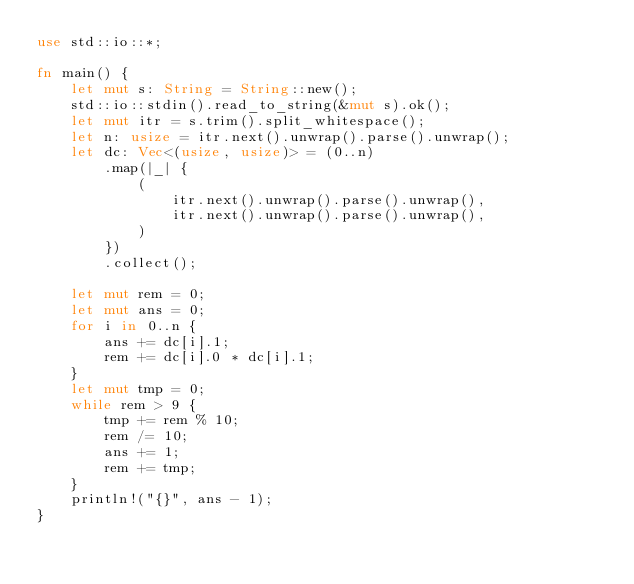Convert code to text. <code><loc_0><loc_0><loc_500><loc_500><_Rust_>use std::io::*;

fn main() {
    let mut s: String = String::new();
    std::io::stdin().read_to_string(&mut s).ok();
    let mut itr = s.trim().split_whitespace();
    let n: usize = itr.next().unwrap().parse().unwrap();
    let dc: Vec<(usize, usize)> = (0..n)
        .map(|_| {
            (
                itr.next().unwrap().parse().unwrap(),
                itr.next().unwrap().parse().unwrap(),
            )
        })
        .collect();

    let mut rem = 0;
    let mut ans = 0;
    for i in 0..n {
        ans += dc[i].1;
        rem += dc[i].0 * dc[i].1;
    }
    let mut tmp = 0;
    while rem > 9 {
        tmp += rem % 10;
        rem /= 10;
        ans += 1;
        rem += tmp;
    }
    println!("{}", ans - 1);
}
</code> 